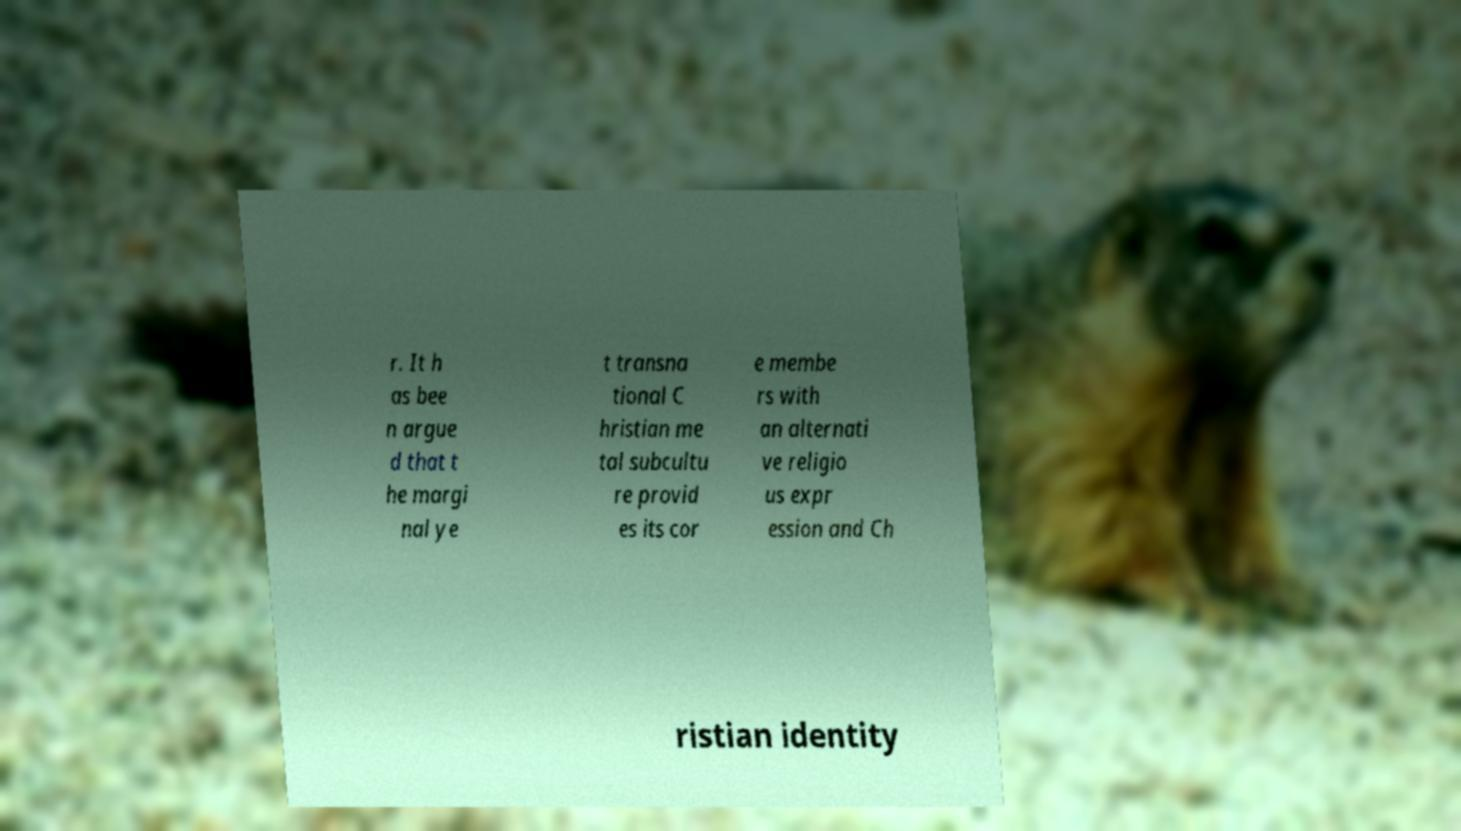I need the written content from this picture converted into text. Can you do that? r. It h as bee n argue d that t he margi nal ye t transna tional C hristian me tal subcultu re provid es its cor e membe rs with an alternati ve religio us expr ession and Ch ristian identity 